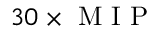<formula> <loc_0><loc_0><loc_500><loc_500>3 0 \times M I P</formula> 